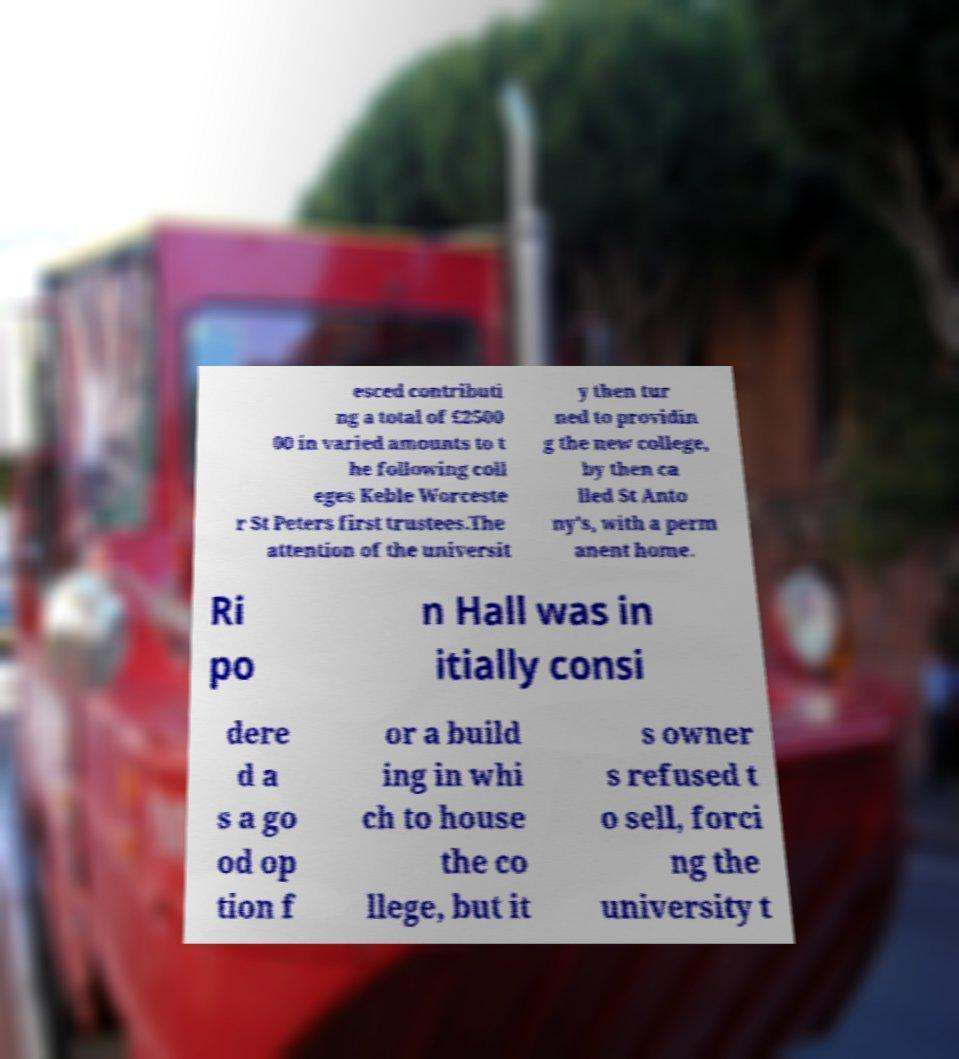I need the written content from this picture converted into text. Can you do that? esced contributi ng a total of £2500 00 in varied amounts to t he following coll eges Keble Worceste r St Peters first trustees.The attention of the universit y then tur ned to providin g the new college, by then ca lled St Anto ny's, with a perm anent home. Ri po n Hall was in itially consi dere d a s a go od op tion f or a build ing in whi ch to house the co llege, but it s owner s refused t o sell, forci ng the university t 